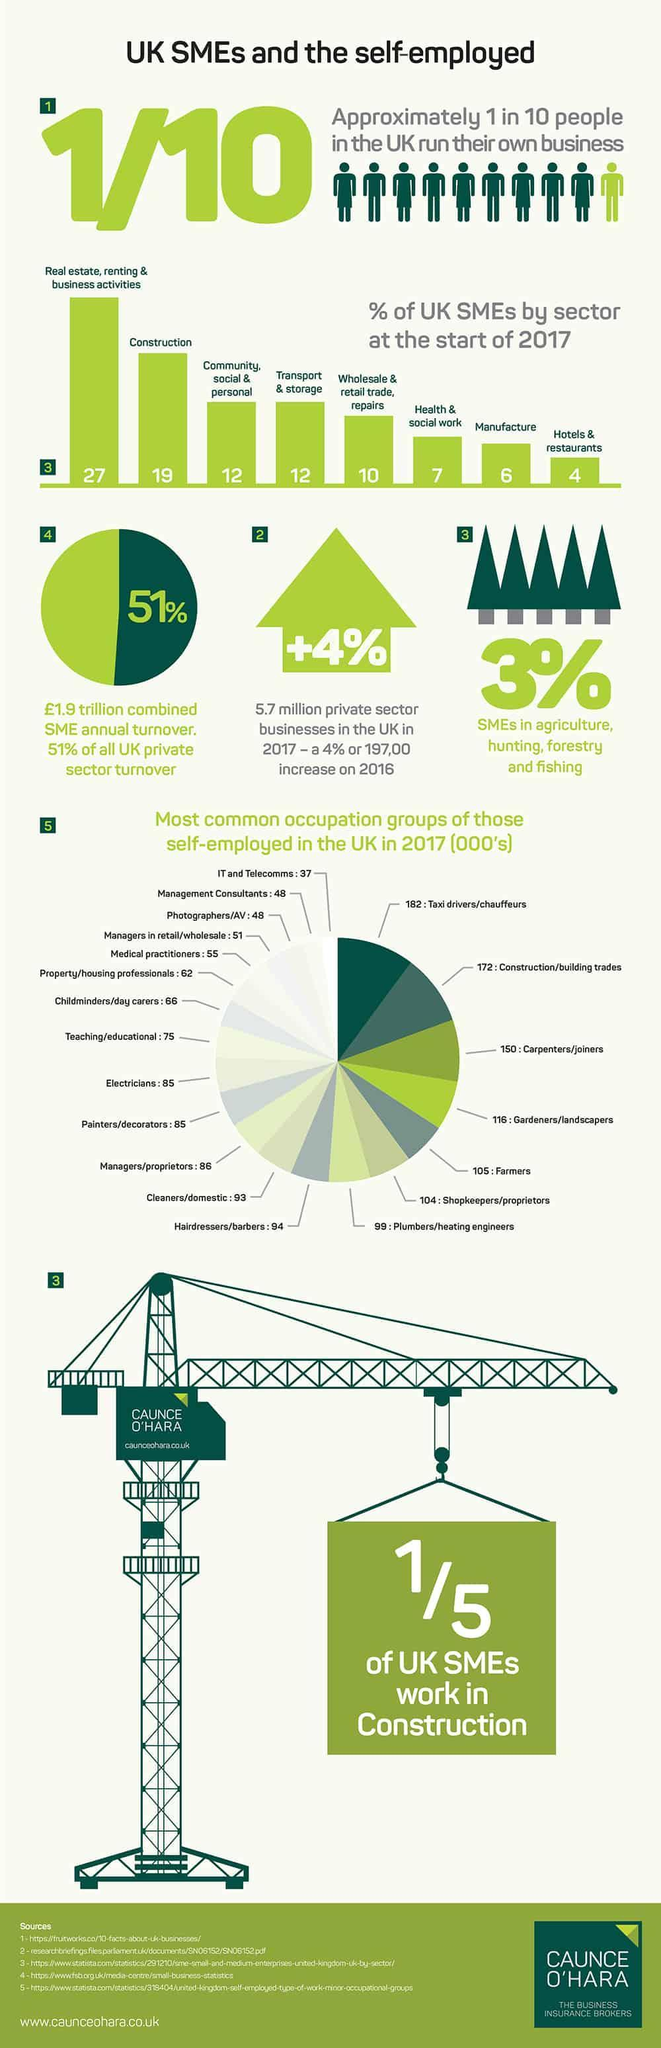What is the total of farmers and electricians taken together?
Answer the question with a short phrase. 190 Which occupation group has the highest share? Taxi drivers/chauffeurs What is the total of painters and joiners taken together? 235 What is the percentage of construction and manufacture taken together? 25 How many tree icons are in this infographic? 5 